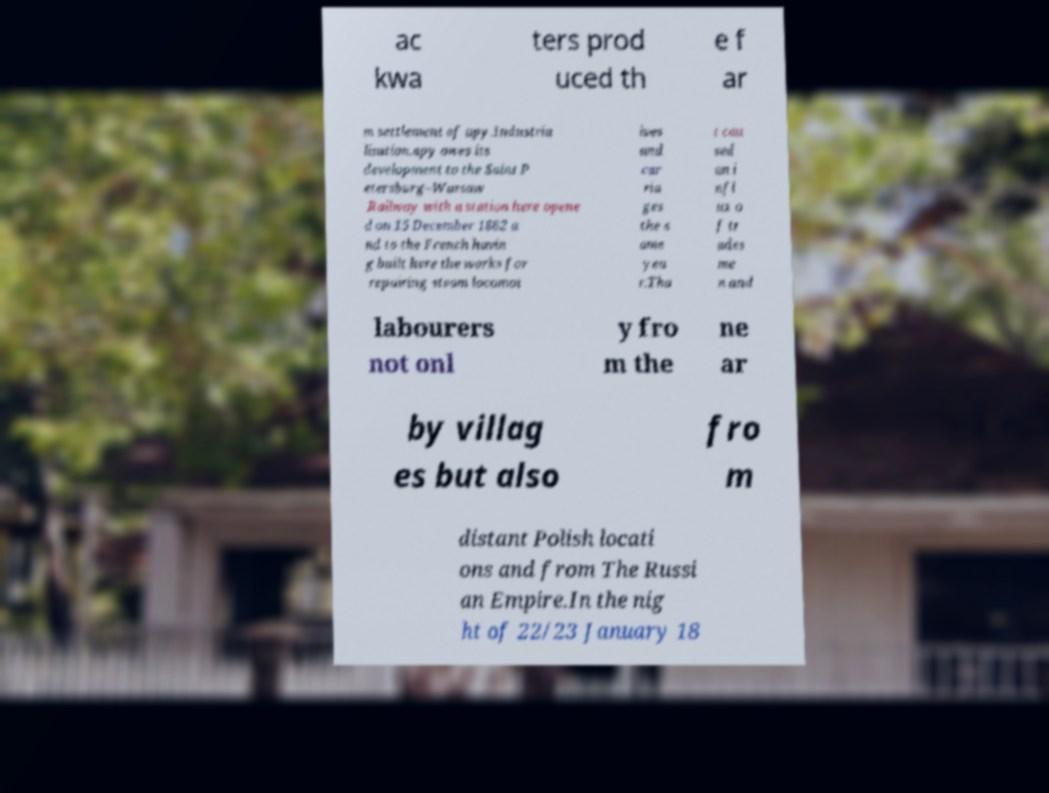What messages or text are displayed in this image? I need them in a readable, typed format. ac kwa ters prod uced th e f ar m settlement of apy.Industria lisation.apy owes its development to the Saint P etersburg–Warsaw Railway with a station here opene d on 15 December 1862 a nd to the French havin g built here the works for repairing steam locomot ives and car ria ges the s ame yea r.Tha t cau sed an i nfl ux o f tr ades me n and labourers not onl y fro m the ne ar by villag es but also fro m distant Polish locati ons and from The Russi an Empire.In the nig ht of 22/23 January 18 